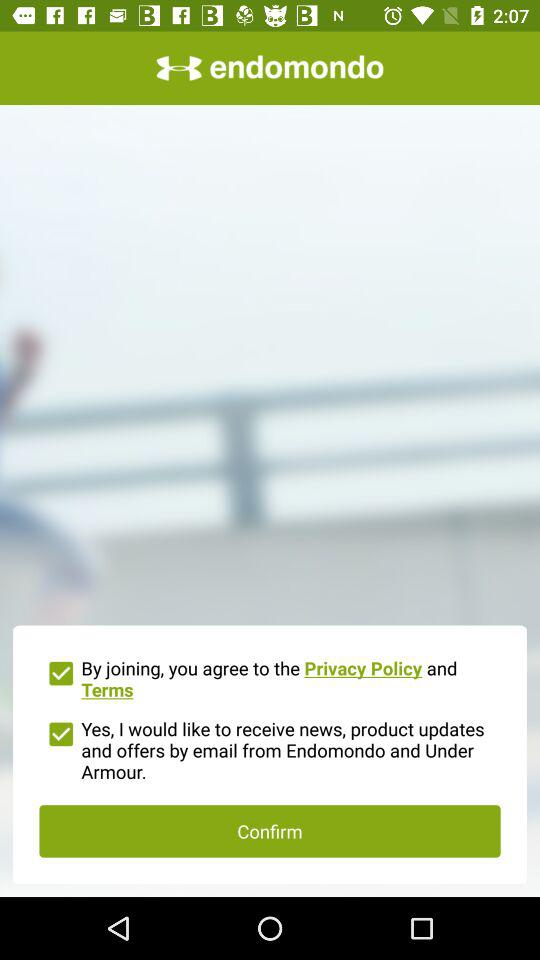What is the name of the application? The name of the application is "endomondo". 